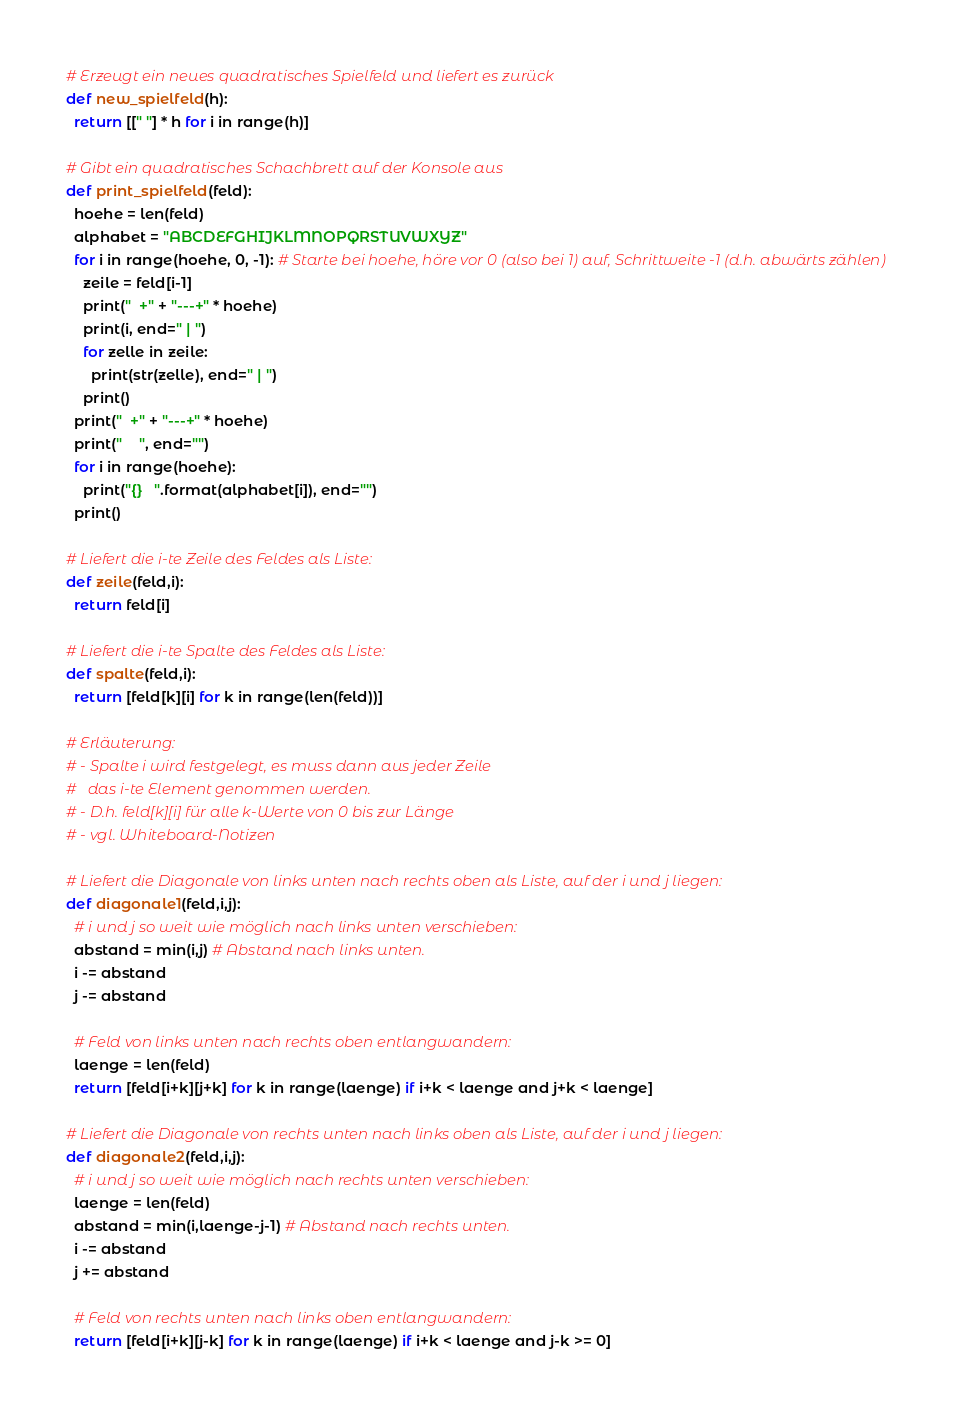<code> <loc_0><loc_0><loc_500><loc_500><_Python_># Erzeugt ein neues quadratisches Spielfeld und liefert es zurück
def new_spielfeld(h):
  return [[" "] * h for i in range(h)]

# Gibt ein quadratisches Schachbrett auf der Konsole aus
def print_spielfeld(feld):
  hoehe = len(feld)
  alphabet = "ABCDEFGHIJKLMNOPQRSTUVWXYZ"
  for i in range(hoehe, 0, -1): # Starte bei hoehe, höre vor 0 (also bei 1) auf, Schrittweite -1 (d.h. abwärts zählen)
    zeile = feld[i-1]
    print("  +" + "---+" * hoehe)
    print(i, end=" | ")
    for zelle in zeile:
      print(str(zelle), end=" | ")
    print()
  print("  +" + "---+" * hoehe)
  print("    ", end="")
  for i in range(hoehe):
    print("{}   ".format(alphabet[i]), end="")
  print()

# Liefert die i-te Zeile des Feldes als Liste:
def zeile(feld,i):
  return feld[i]

# Liefert die i-te Spalte des Feldes als Liste:
def spalte(feld,i):
  return [feld[k][i] for k in range(len(feld))]

# Erläuterung:
# - Spalte i wird festgelegt, es muss dann aus jeder Zeile
#   das i-te Element genommen werden.
# - D.h. feld[k][i] für alle k-Werte von 0 bis zur Länge
# - vgl. Whiteboard-Notizen

# Liefert die Diagonale von links unten nach rechts oben als Liste, auf der i und j liegen:
def diagonale1(feld,i,j):
  # i und j so weit wie möglich nach links unten verschieben:
  abstand = min(i,j) # Abstand nach links unten.
  i -= abstand
  j -= abstand

  # Feld von links unten nach rechts oben entlangwandern:
  laenge = len(feld)
  return [feld[i+k][j+k] for k in range(laenge) if i+k < laenge and j+k < laenge]

# Liefert die Diagonale von rechts unten nach links oben als Liste, auf der i und j liegen:
def diagonale2(feld,i,j):
  # i und j so weit wie möglich nach rechts unten verschieben:
  laenge = len(feld)
  abstand = min(i,laenge-j-1) # Abstand nach rechts unten.
  i -= abstand
  j += abstand

  # Feld von rechts unten nach links oben entlangwandern:
  return [feld[i+k][j-k] for k in range(laenge) if i+k < laenge and j-k >= 0]</code> 